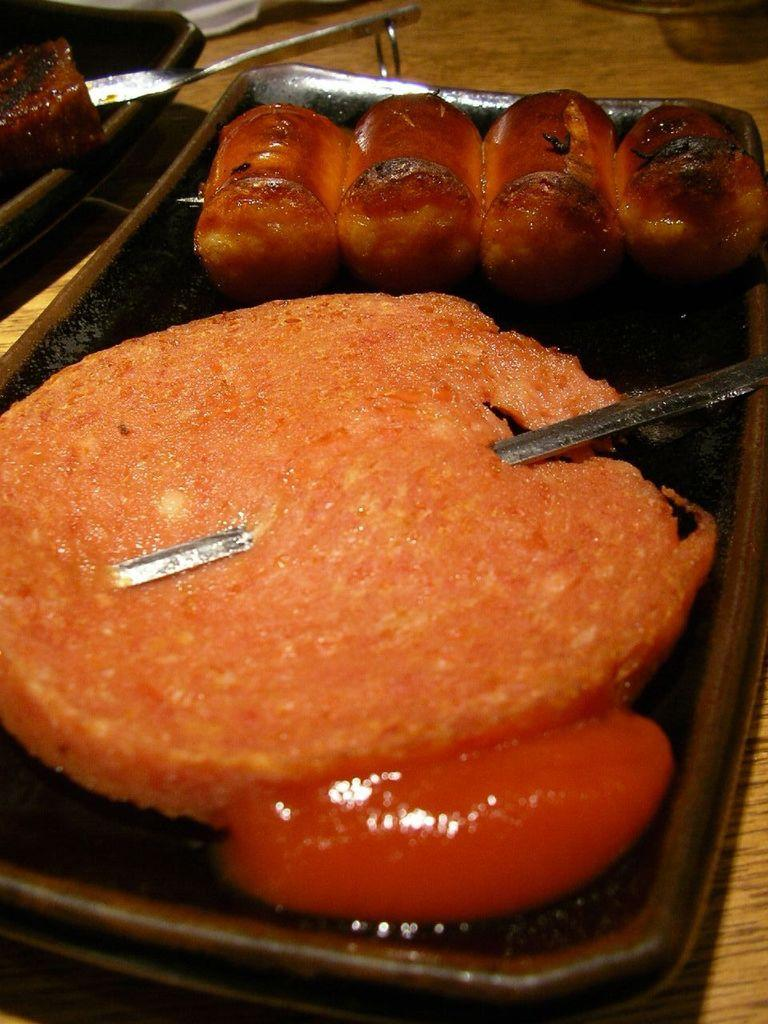What is on the tray that is visible in the image? There is food on a tray in the image. What type of objects are in the foreground of the image? There are metal objects in the foreground of the image. What can be seen in the background of the image? There are objects visible in the background of the image. What piece of furniture is present in the image? There is a table in the image. Can you hear the brother laughing in the image? There is no mention of a brother or laughter in the image, so it cannot be heard. 